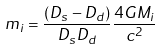Convert formula to latex. <formula><loc_0><loc_0><loc_500><loc_500>m _ { i } = \frac { ( D _ { s } - D _ { d } ) } { D _ { s } D _ { d } } \frac { 4 G M _ { i } } { c ^ { 2 } }</formula> 